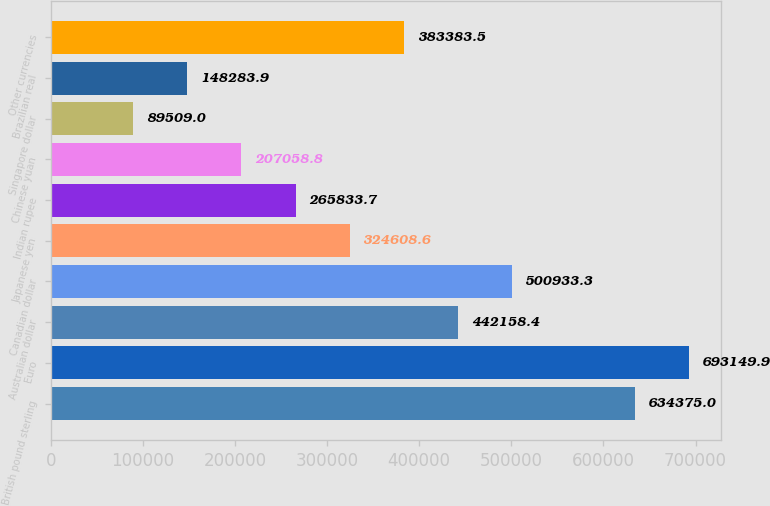Convert chart to OTSL. <chart><loc_0><loc_0><loc_500><loc_500><bar_chart><fcel>British pound sterling<fcel>Euro<fcel>Australian dollar<fcel>Canadian dollar<fcel>Japanese yen<fcel>Indian rupee<fcel>Chinese yuan<fcel>Singapore dollar<fcel>Brazilian real<fcel>Other currencies<nl><fcel>634375<fcel>693150<fcel>442158<fcel>500933<fcel>324609<fcel>265834<fcel>207059<fcel>89509<fcel>148284<fcel>383384<nl></chart> 